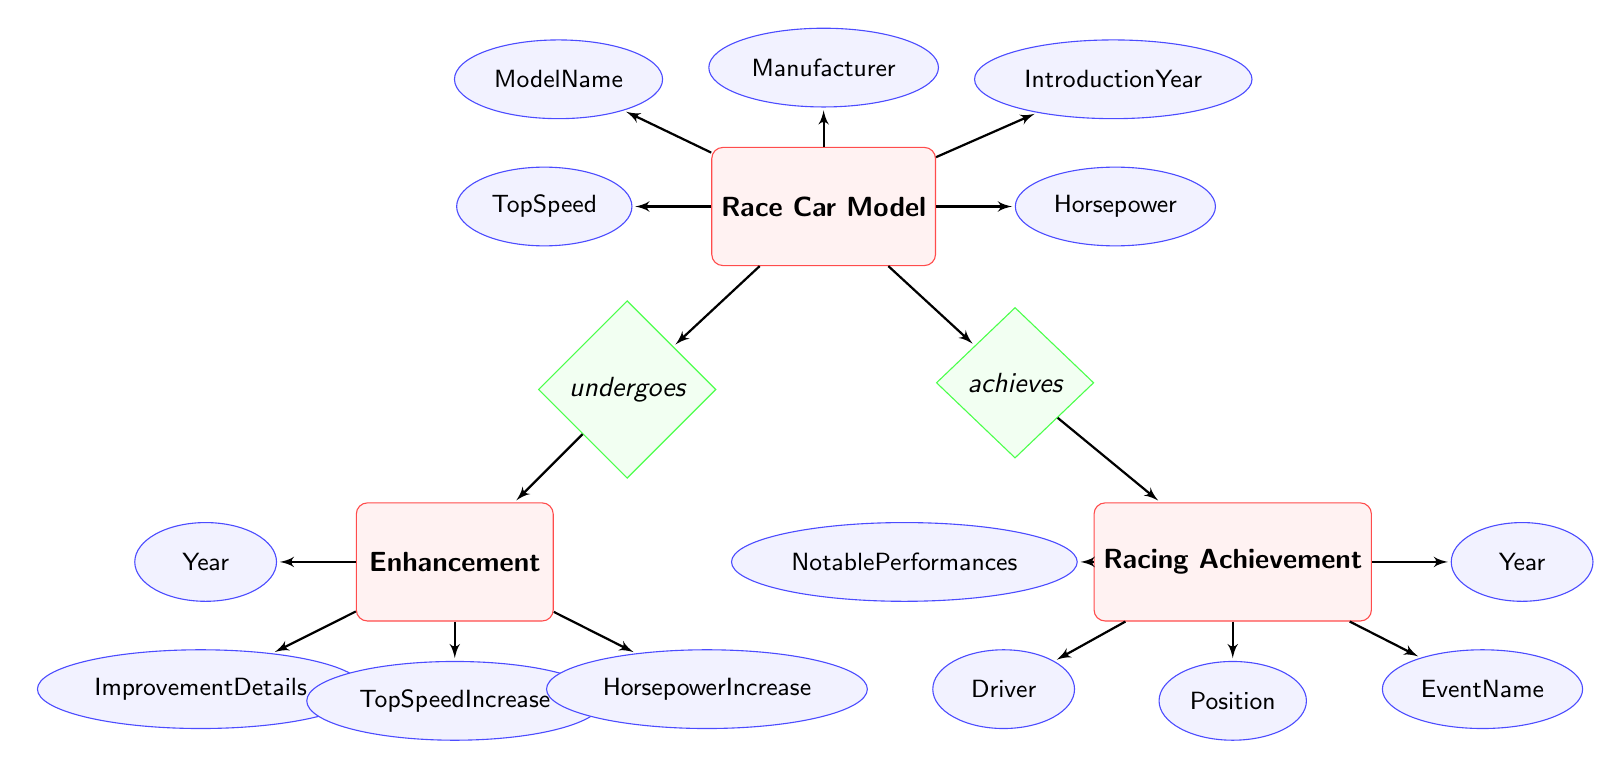What is the primary entity depicted in the diagram? The diagram showcases the entity "Race Car Model," which is central to the relationships illustrated with enhancements and achievements connected to it.
Answer: Race Car Model How many attributes does the Racing Achievement entity have? The "Racing Achievement" entity possesses five attributes: Year, EventName, Position, Driver, and NotablePerformances, as represented in the diagram.
Answer: 5 What relationship connects the Race Car Model and Enhancement entities? The relationship labeled "undergoes" connects the "Race Car Model" entity to the "Enhancement" entity, indicating a direct association between them regarding upgrades or changes.
Answer: undergoes Which enhancement attribute specifies the year of enhancement? The attribute "Year" within the "Enhancement" entity specifically denotes the year in which the enhancement occurred, as shown in the diagram.
Answer: Year What is the nature of the relationship between Race Car Model and Racing Achievement? The nature of the connection is represented by the relationship "achieves," indicating that the race car model reaches specific racing achievements over time.
Answer: achieves Which entity has the attribute "TopSpeed"? The attribute "TopSpeed" belongs to the "Race Car Model" entity, reflecting the maximum speed the race car can attain, as illustrated in the diagram.
Answer: Race Car Model What type of diagram is this? The diagram presented is an Entity Relationship Diagram, which illustrates entities and their interrelations, specifically for enhancements and achievements related to race car models.
Answer: Entity Relationship Diagram How many nodes are there in total in the diagram? The diagram consists of three entities and their respective attributes, resulting in a total of fifteen nodes when attributes are counted as separate.
Answer: 15 What is the attribute that indicates the improvements in horsepower for the enhancements? The attribute "HorsepowerIncrease" within the "Enhancement" entity specifically indicates the improvements made in horsepower as a result of enhancements.
Answer: HorsepowerIncrease 